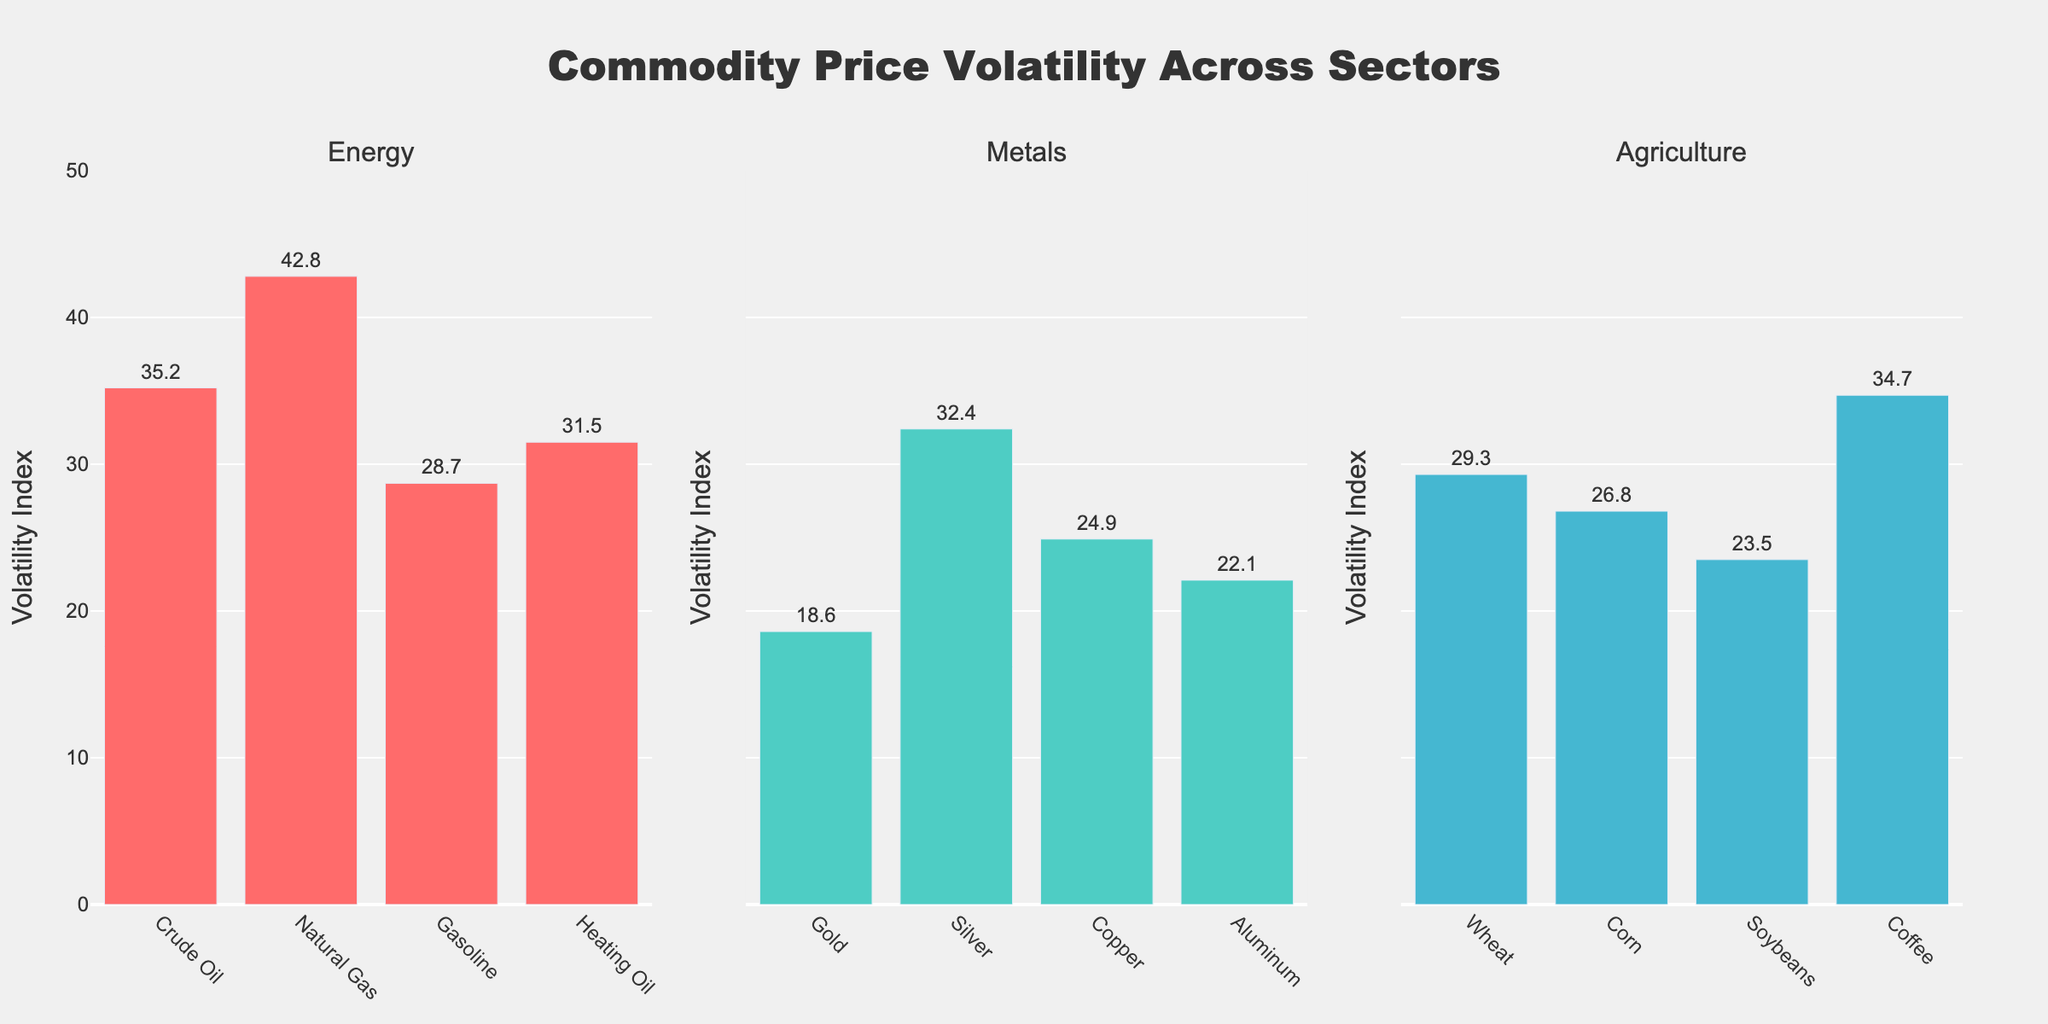What does the title of the figure indicate? The title is located at the top of the figure and it reads "Commodity Price Volatility Across Sectors". This indicates that the figure displays the volatility of prices for various commodities segmented by different sectors.
Answer: Commodity Price Volatility Across Sectors How many commodities are listed under the Metals sector? To determine this, check the number of bars in the sub-plot titled "Metals". There are four bars shown.
Answer: 4 Which commodity in the Energy sector has the highest volatility index? Identify the bar with the highest value in the Energy sector subplot. The tallest bar represents Natural Gas.
Answer: Natural Gas Which commodity in the Agriculture sector has the lowest volatility index? Look at the bars in the Agriculture sector subplot and identify the shortest bar. The shortest bar represents Soybeans.
Answer: Soybeans What is the overall range of the volatility index shown in the figure? Consider the range of values on the y-axis that starts from 0 and goes up to the maximum value on the chart which is slightly above 40. The maximum shown is approximately 43. Thus, the range is from 0 to 43.
Answer: 0 to 43 What is the average volatility index of the commodities within the Agriculture sector? To find the average, add the volatility indices of Wheat (29.3), Corn (26.8), Soybeans (23.5), and Coffee (34.7) then divide by 4. (29.3 + 26.8 + 23.5 + 34.7) / 4 = 28.575
Answer: 28.6 How does the volatility of Gold compare to that of Silver? Compare the height of the bars representing Gold and Silver in the Metals sector subplot. Gold has a volatility index of 18.6 while Silver has a higher value of 32.4. Thus, Silver is more volatile than Gold.
Answer: Silver is more volatile than Gold By how much does the volatility of Crude Oil differ from that of Heating Oil in the Energy sector? Subtract the volatility index of Heating Oil (31.5) from that of Crude Oil (35.2). 35.2 - 31.5 = 3.7
Answer: 3.7 Which sector exhibits the widest range of volatility indices? Compare the ranges for each sector by subtracting the lowest volatility value from the highest within each sector. Energy: (42.8 - 28.7 = 14.1), Metals: (32.4 - 18.6 = 13.8), Agriculture: (34.7 - 23.5 = 11.2). Energy has the widest range.
Answer: Energy 